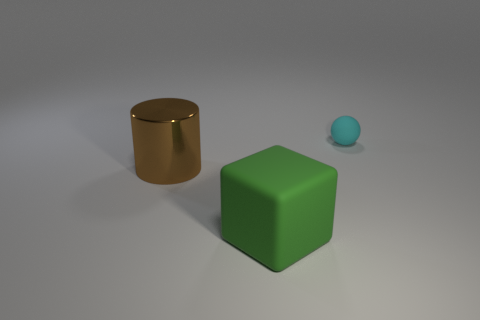Add 1 brown metal things. How many objects exist? 4 Subtract 0 yellow blocks. How many objects are left? 3 Subtract all spheres. How many objects are left? 2 Subtract all brown cylinders. Subtract all large shiny objects. How many objects are left? 1 Add 2 tiny rubber spheres. How many tiny rubber spheres are left? 3 Add 1 big brown cylinders. How many big brown cylinders exist? 2 